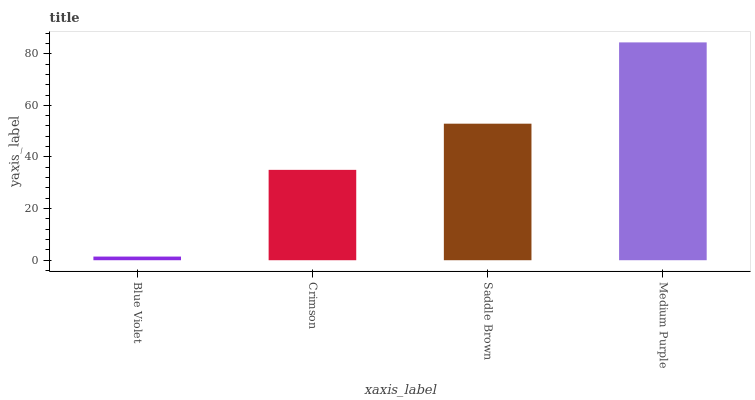Is Blue Violet the minimum?
Answer yes or no. Yes. Is Medium Purple the maximum?
Answer yes or no. Yes. Is Crimson the minimum?
Answer yes or no. No. Is Crimson the maximum?
Answer yes or no. No. Is Crimson greater than Blue Violet?
Answer yes or no. Yes. Is Blue Violet less than Crimson?
Answer yes or no. Yes. Is Blue Violet greater than Crimson?
Answer yes or no. No. Is Crimson less than Blue Violet?
Answer yes or no. No. Is Saddle Brown the high median?
Answer yes or no. Yes. Is Crimson the low median?
Answer yes or no. Yes. Is Crimson the high median?
Answer yes or no. No. Is Blue Violet the low median?
Answer yes or no. No. 